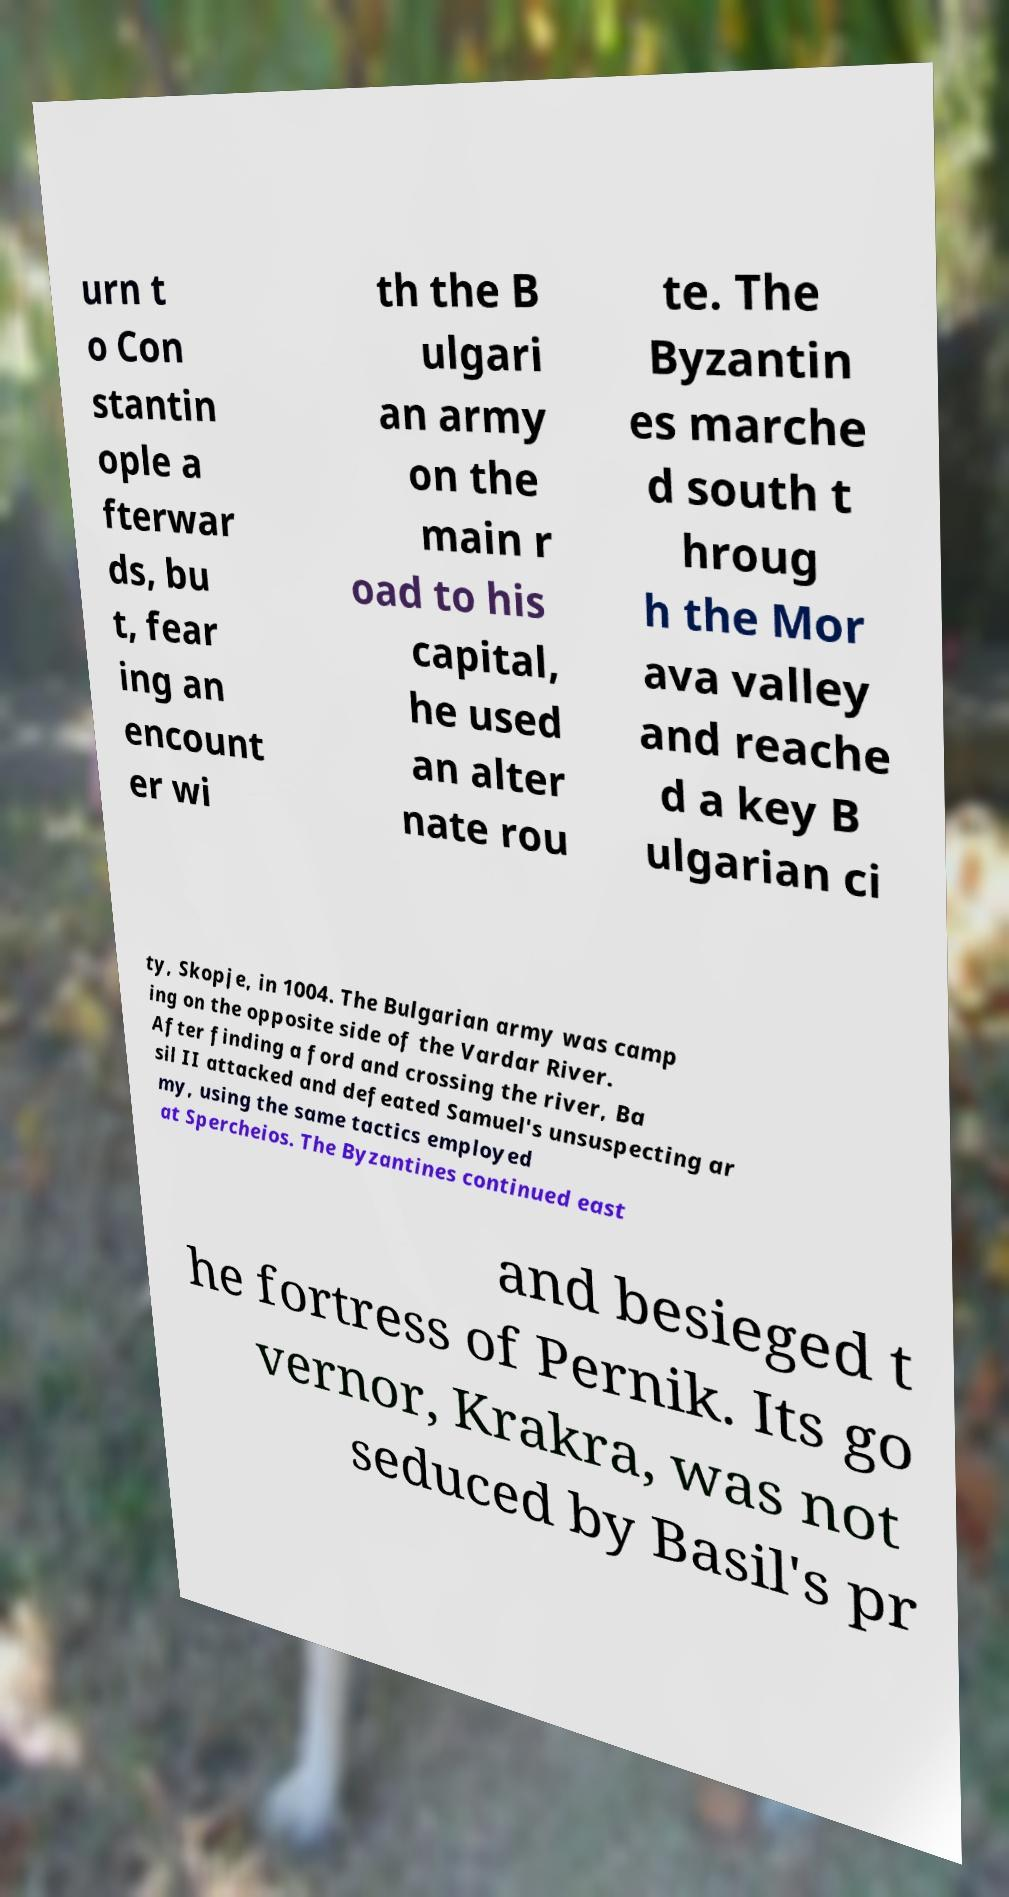Can you read and provide the text displayed in the image?This photo seems to have some interesting text. Can you extract and type it out for me? urn t o Con stantin ople a fterwar ds, bu t, fear ing an encount er wi th the B ulgari an army on the main r oad to his capital, he used an alter nate rou te. The Byzantin es marche d south t hroug h the Mor ava valley and reache d a key B ulgarian ci ty, Skopje, in 1004. The Bulgarian army was camp ing on the opposite side of the Vardar River. After finding a ford and crossing the river, Ba sil II attacked and defeated Samuel's unsuspecting ar my, using the same tactics employed at Spercheios. The Byzantines continued east and besieged t he fortress of Pernik. Its go vernor, Krakra, was not seduced by Basil's pr 